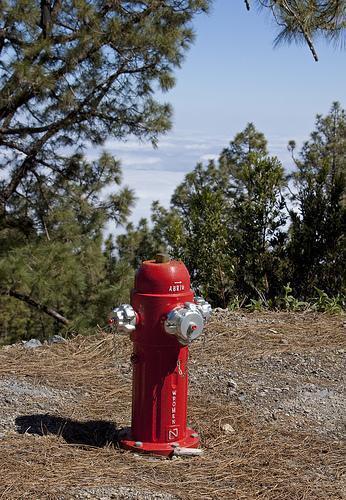How many fire hydrants are there?
Give a very brief answer. 1. 